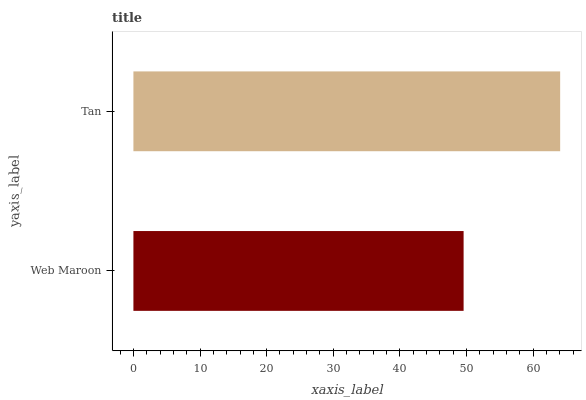Is Web Maroon the minimum?
Answer yes or no. Yes. Is Tan the maximum?
Answer yes or no. Yes. Is Tan the minimum?
Answer yes or no. No. Is Tan greater than Web Maroon?
Answer yes or no. Yes. Is Web Maroon less than Tan?
Answer yes or no. Yes. Is Web Maroon greater than Tan?
Answer yes or no. No. Is Tan less than Web Maroon?
Answer yes or no. No. Is Tan the high median?
Answer yes or no. Yes. Is Web Maroon the low median?
Answer yes or no. Yes. Is Web Maroon the high median?
Answer yes or no. No. Is Tan the low median?
Answer yes or no. No. 